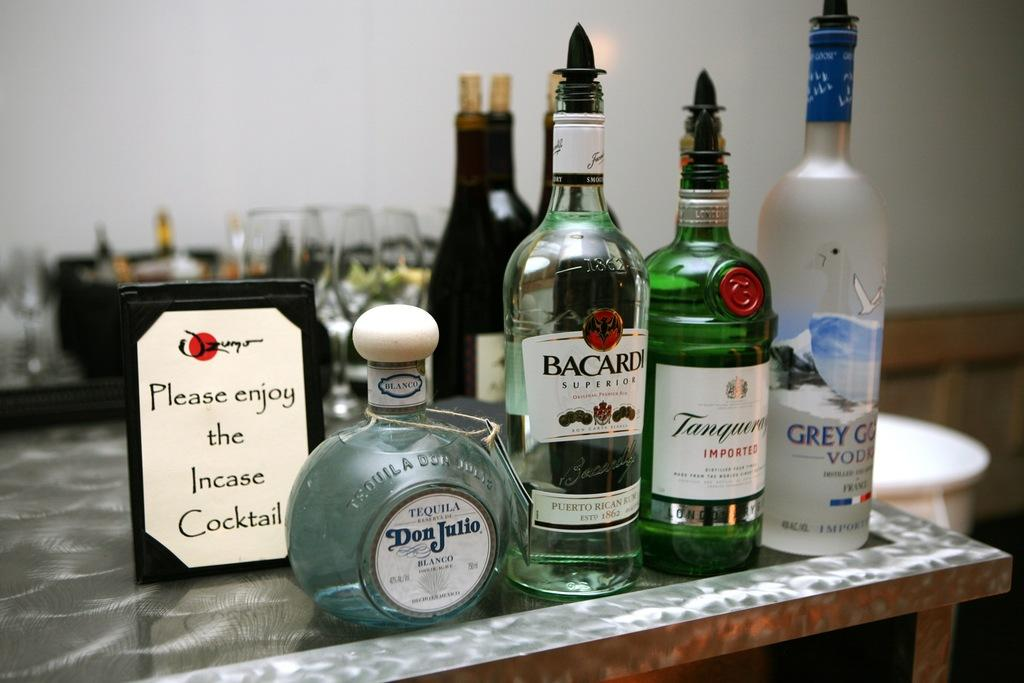<image>
Provide a brief description of the given image. Lots of bottles of alcohol, one of which is Barcardi. 